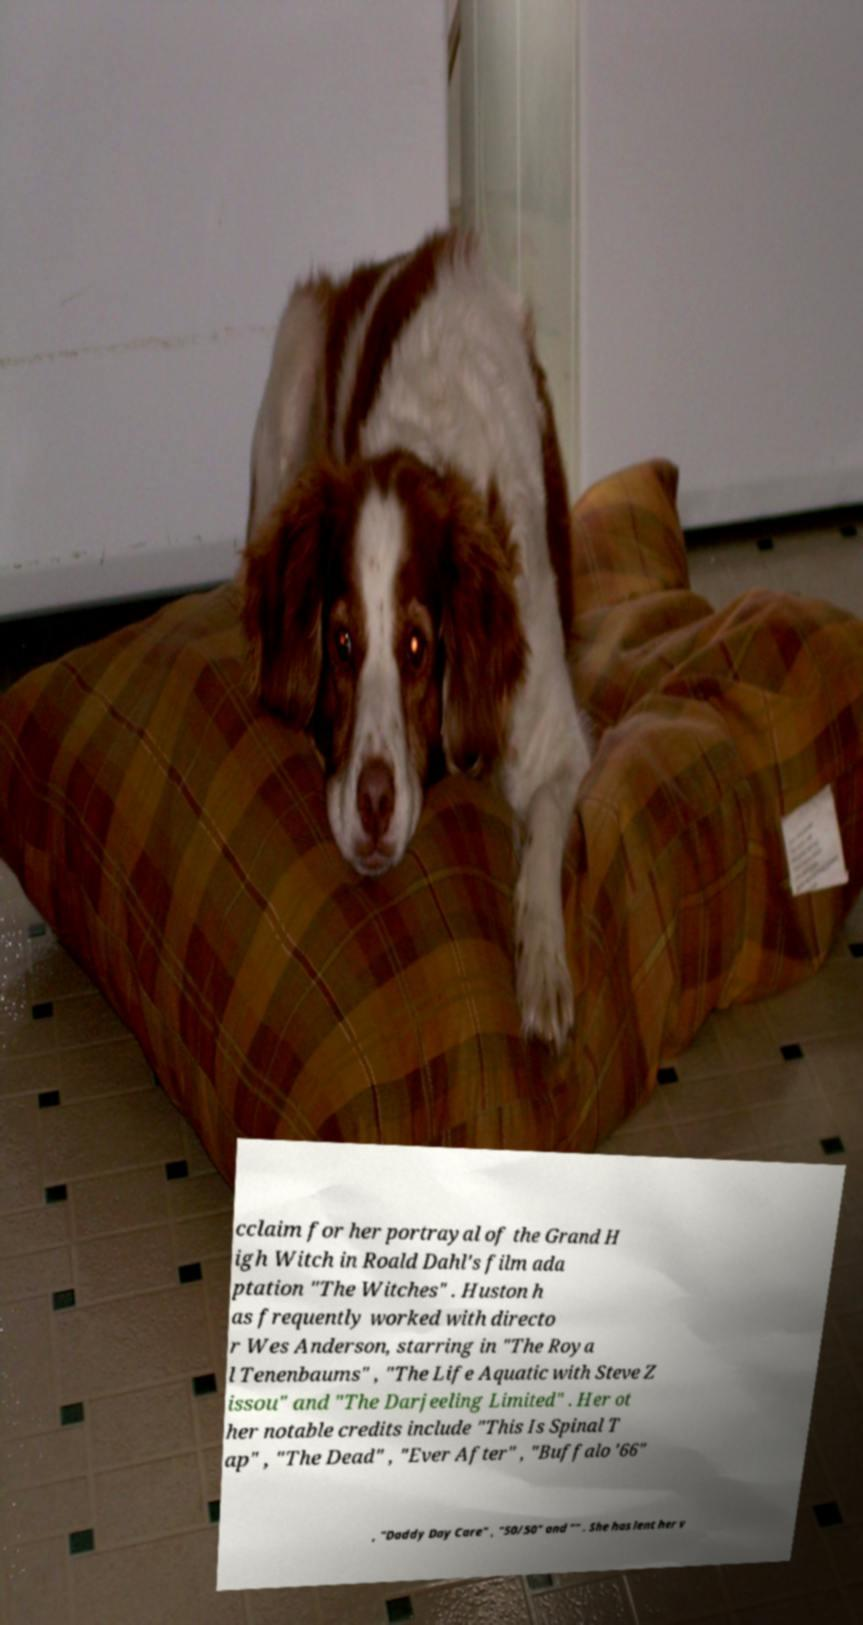There's text embedded in this image that I need extracted. Can you transcribe it verbatim? cclaim for her portrayal of the Grand H igh Witch in Roald Dahl's film ada ptation "The Witches" . Huston h as frequently worked with directo r Wes Anderson, starring in "The Roya l Tenenbaums" , "The Life Aquatic with Steve Z issou" and "The Darjeeling Limited" . Her ot her notable credits include "This Is Spinal T ap" , "The Dead" , "Ever After" , "Buffalo '66" , "Daddy Day Care" , "50/50" and "" . She has lent her v 